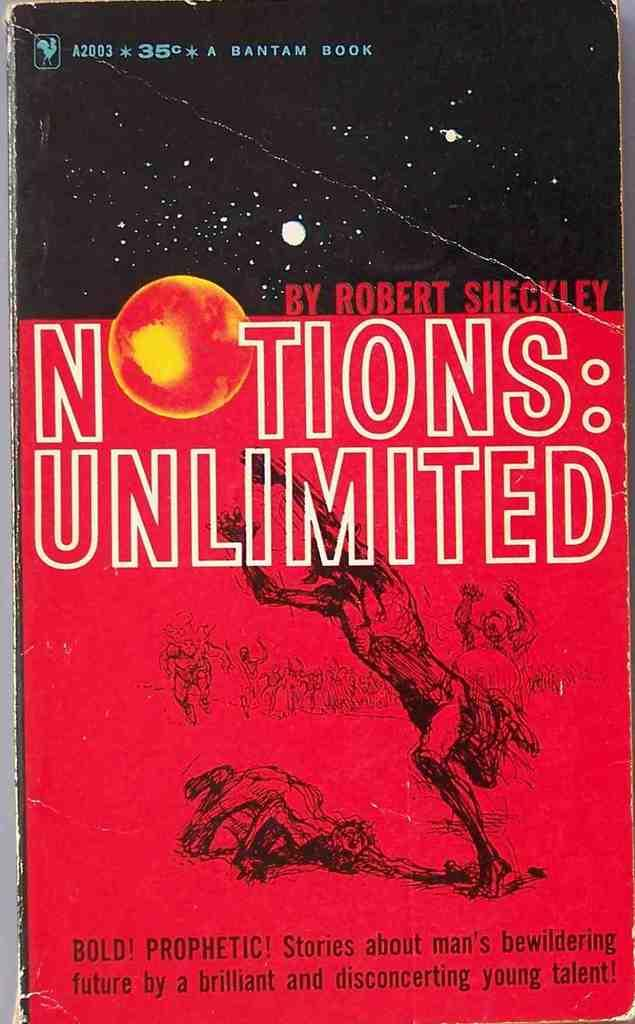<image>
Describe the image concisely. The cover of a book by Robert Sheckley is shown. 